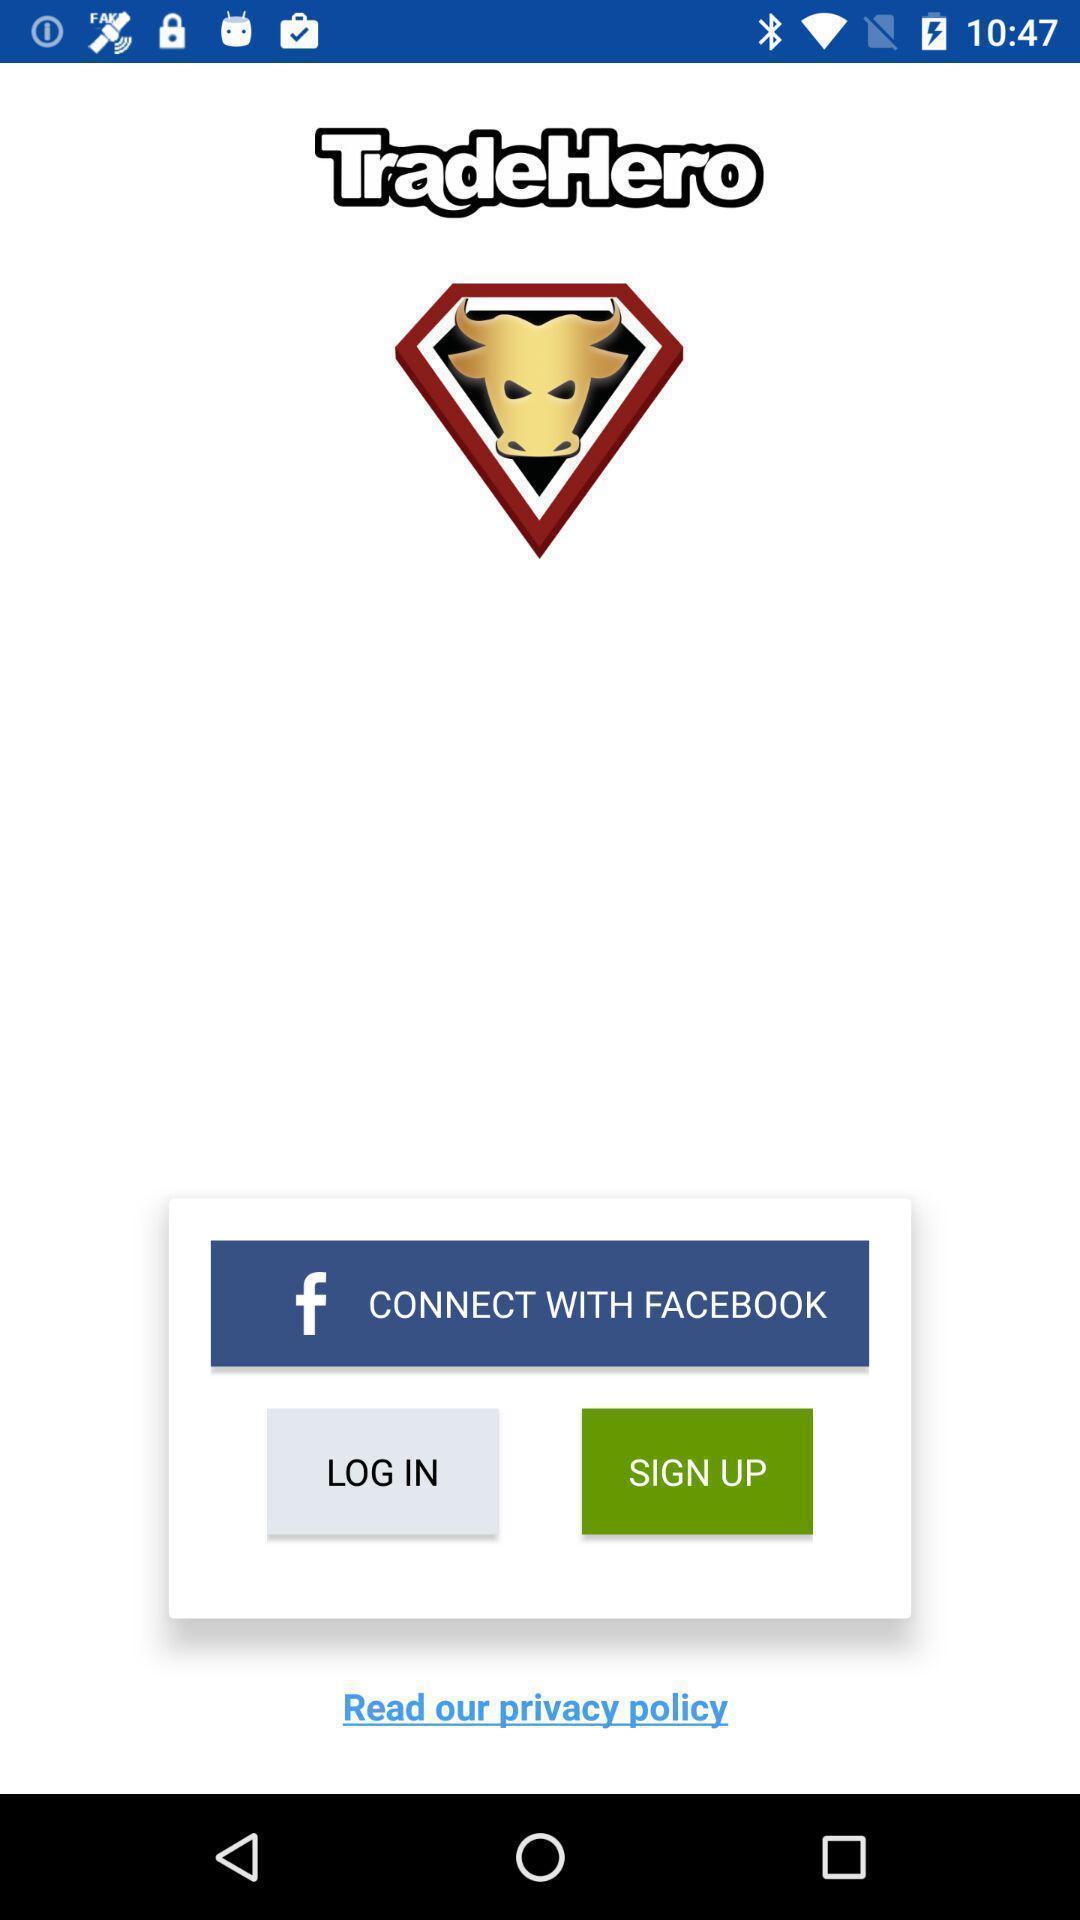Tell me what you see in this picture. Welcome page of trading app. 